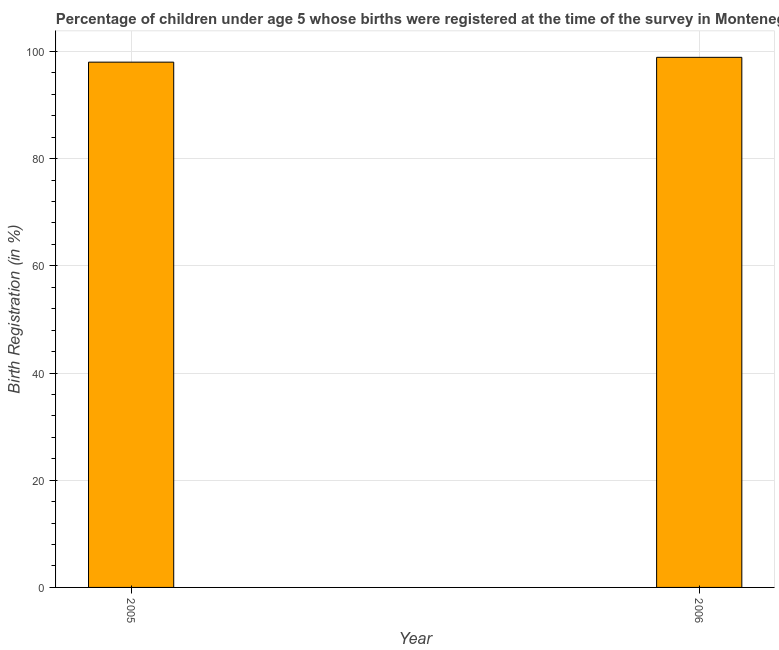Does the graph contain any zero values?
Your response must be concise. No. Does the graph contain grids?
Your response must be concise. Yes. What is the title of the graph?
Provide a short and direct response. Percentage of children under age 5 whose births were registered at the time of the survey in Montenegro. What is the label or title of the X-axis?
Your answer should be compact. Year. What is the label or title of the Y-axis?
Provide a short and direct response. Birth Registration (in %). What is the birth registration in 2006?
Your answer should be compact. 98.9. Across all years, what is the maximum birth registration?
Your response must be concise. 98.9. What is the sum of the birth registration?
Your response must be concise. 196.9. What is the difference between the birth registration in 2005 and 2006?
Offer a terse response. -0.9. What is the average birth registration per year?
Ensure brevity in your answer.  98.45. What is the median birth registration?
Provide a short and direct response. 98.45. In how many years, is the birth registration greater than 92 %?
Make the answer very short. 2. Do a majority of the years between 2006 and 2005 (inclusive) have birth registration greater than 52 %?
Your answer should be compact. No. In how many years, is the birth registration greater than the average birth registration taken over all years?
Your response must be concise. 1. How many years are there in the graph?
Your answer should be compact. 2. What is the Birth Registration (in %) of 2006?
Your response must be concise. 98.9. What is the difference between the Birth Registration (in %) in 2005 and 2006?
Offer a very short reply. -0.9. 